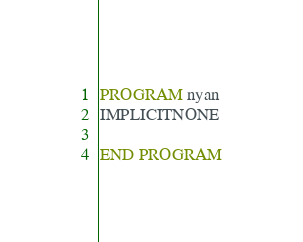Convert code to text. <code><loc_0><loc_0><loc_500><loc_500><_FORTRAN_>PROGRAM nyan
IMPLICITNONE

END PROGRAM</code> 